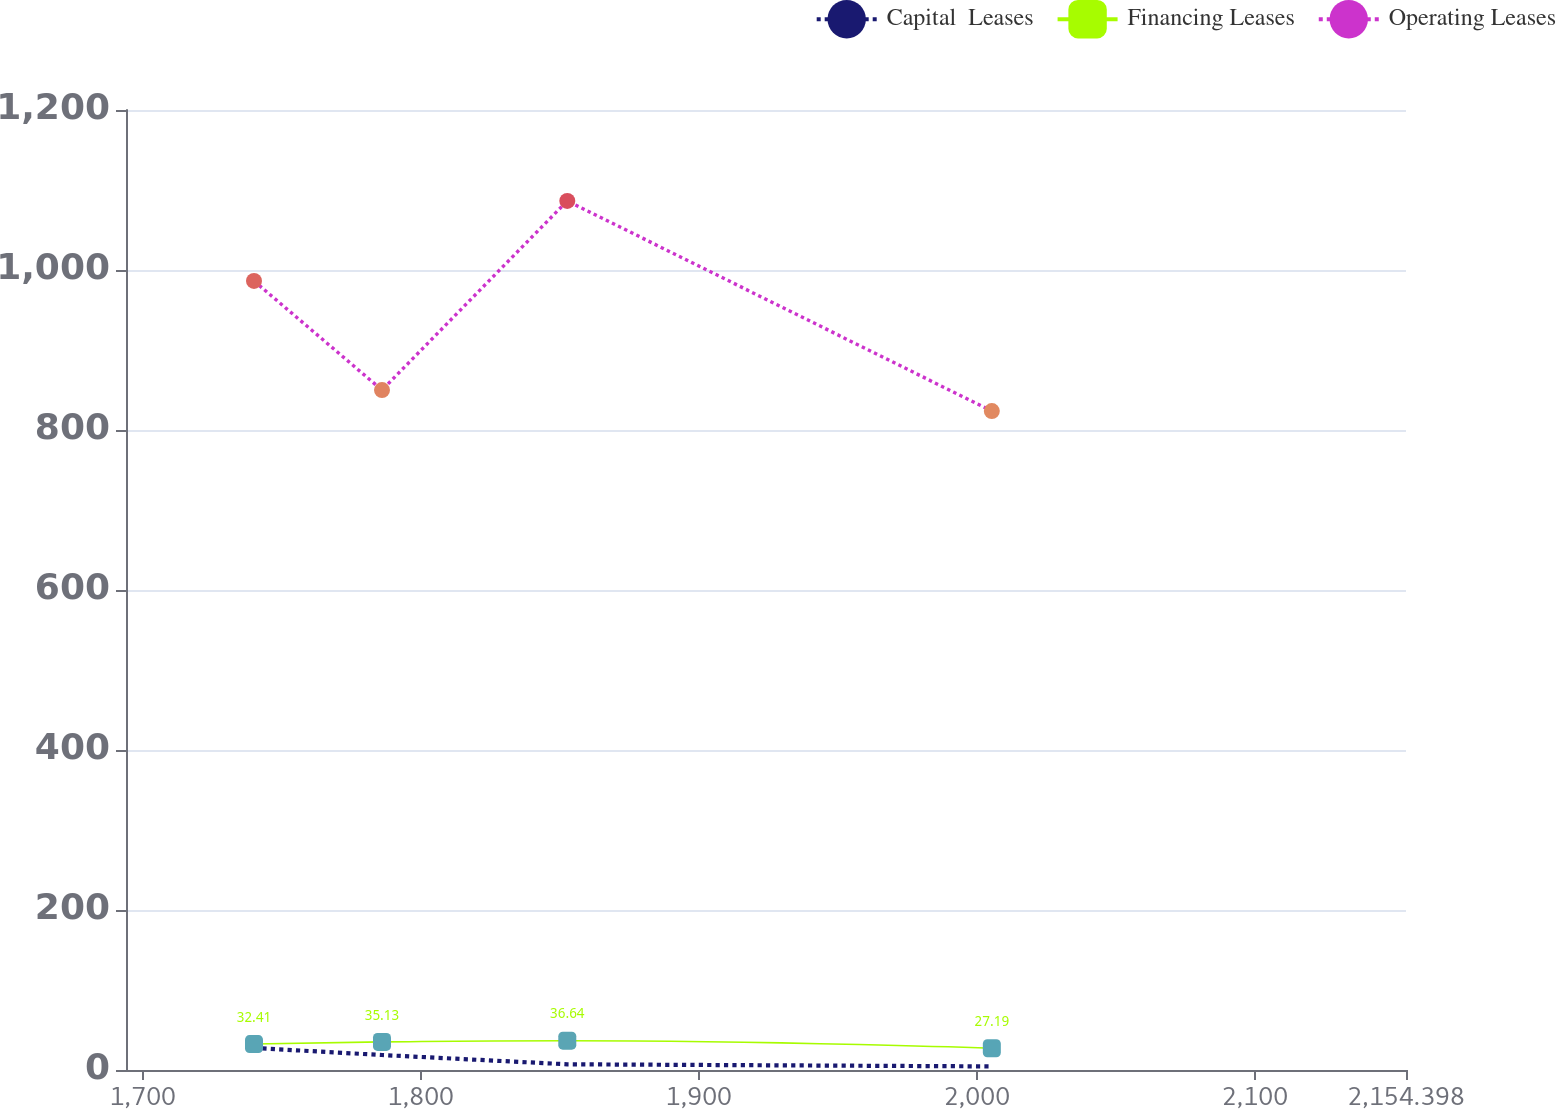Convert chart to OTSL. <chart><loc_0><loc_0><loc_500><loc_500><line_chart><ecel><fcel>Capital  Leases<fcel>Financing Leases<fcel>Operating Leases<nl><fcel>1740.02<fcel>27.53<fcel>32.41<fcel>986.29<nl><fcel>1786.06<fcel>18.73<fcel>35.13<fcel>849.95<nl><fcel>1852.71<fcel>7.13<fcel>36.64<fcel>1086.37<nl><fcel>2005.42<fcel>4.49<fcel>27.19<fcel>823.68<nl><fcel>2200.44<fcel>1.93<fcel>23.73<fcel>885.09<nl></chart> 